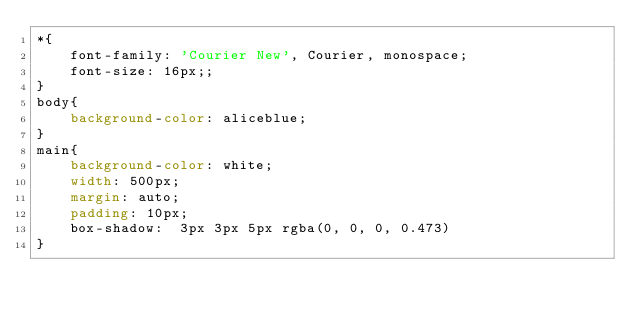Convert code to text. <code><loc_0><loc_0><loc_500><loc_500><_CSS_>*{
    font-family: 'Courier New', Courier, monospace;
    font-size: 16px;;
}
body{
    background-color: aliceblue;
}
main{
    background-color: white;
    width: 500px;
    margin: auto;
    padding: 10px;
    box-shadow:  3px 3px 5px rgba(0, 0, 0, 0.473)
}</code> 